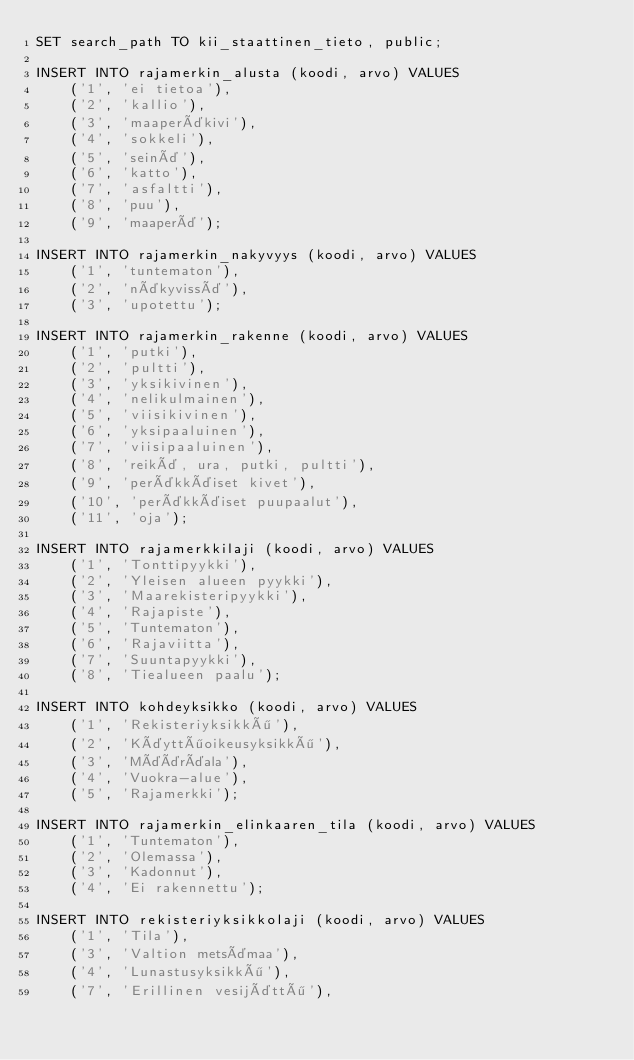<code> <loc_0><loc_0><loc_500><loc_500><_SQL_>SET search_path TO kii_staattinen_tieto, public;

INSERT INTO rajamerkin_alusta (koodi, arvo) VALUES
    ('1', 'ei tietoa'),
    ('2', 'kallio'),
    ('3', 'maaperäkivi'),
    ('4', 'sokkeli'),
    ('5', 'seinä'),
    ('6', 'katto'),
    ('7', 'asfaltti'),
    ('8', 'puu'),
    ('9', 'maaperä');

INSERT INTO rajamerkin_nakyvyys (koodi, arvo) VALUES
    ('1', 'tuntematon'),
    ('2', 'näkyvissä'),
    ('3', 'upotettu');

INSERT INTO rajamerkin_rakenne (koodi, arvo) VALUES
    ('1', 'putki'),
    ('2', 'pultti'),
    ('3', 'yksikivinen'),
    ('4', 'nelikulmainen'),
    ('5', 'viisikivinen'),
    ('6', 'yksipaaluinen'),
    ('7', 'viisipaaluinen'),
    ('8', 'reikä, ura, putki, pultti'),
    ('9', 'peräkkäiset kivet'),
    ('10', 'peräkkäiset puupaalut'),
    ('11', 'oja');

INSERT INTO rajamerkkilaji (koodi, arvo) VALUES
    ('1', 'Tonttipyykki'),
    ('2', 'Yleisen alueen pyykki'),
    ('3', 'Maarekisteripyykki'),
    ('4', 'Rajapiste'),
    ('5', 'Tuntematon'),
    ('6', 'Rajaviitta'),
    ('7', 'Suuntapyykki'),
    ('8', 'Tiealueen paalu');

INSERT INTO kohdeyksikko (koodi, arvo) VALUES
    ('1', 'Rekisteriyksikkö'),
    ('2', 'Käyttöoikeusyksikkö'),
    ('3', 'Määräala'),
    ('4', 'Vuokra-alue'),
    ('5', 'Rajamerkki');

INSERT INTO rajamerkin_elinkaaren_tila (koodi, arvo) VALUES
    ('1', 'Tuntematon'),
    ('2', 'Olemassa'),
    ('3', 'Kadonnut'),
    ('4', 'Ei rakennettu');

INSERT INTO rekisteriyksikkolaji (koodi, arvo) VALUES
    ('1', 'Tila'),
    ('3', 'Valtion metsämaa'),
    ('4', 'Lunastusyksikkö'),
    ('7', 'Erillinen vesijättö'),</code> 